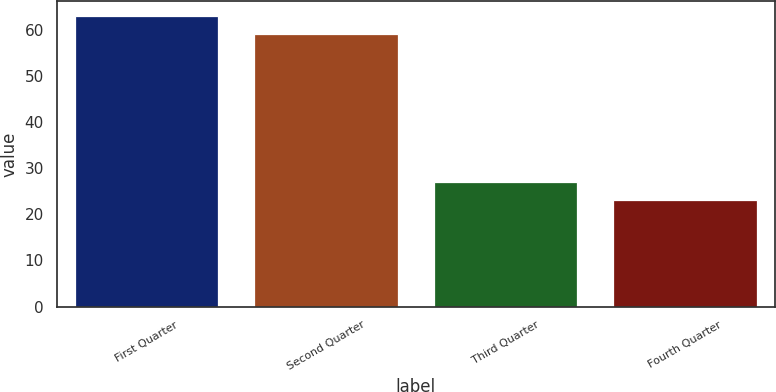<chart> <loc_0><loc_0><loc_500><loc_500><bar_chart><fcel>First Quarter<fcel>Second Quarter<fcel>Third Quarter<fcel>Fourth Quarter<nl><fcel>63<fcel>59<fcel>27<fcel>23<nl></chart> 